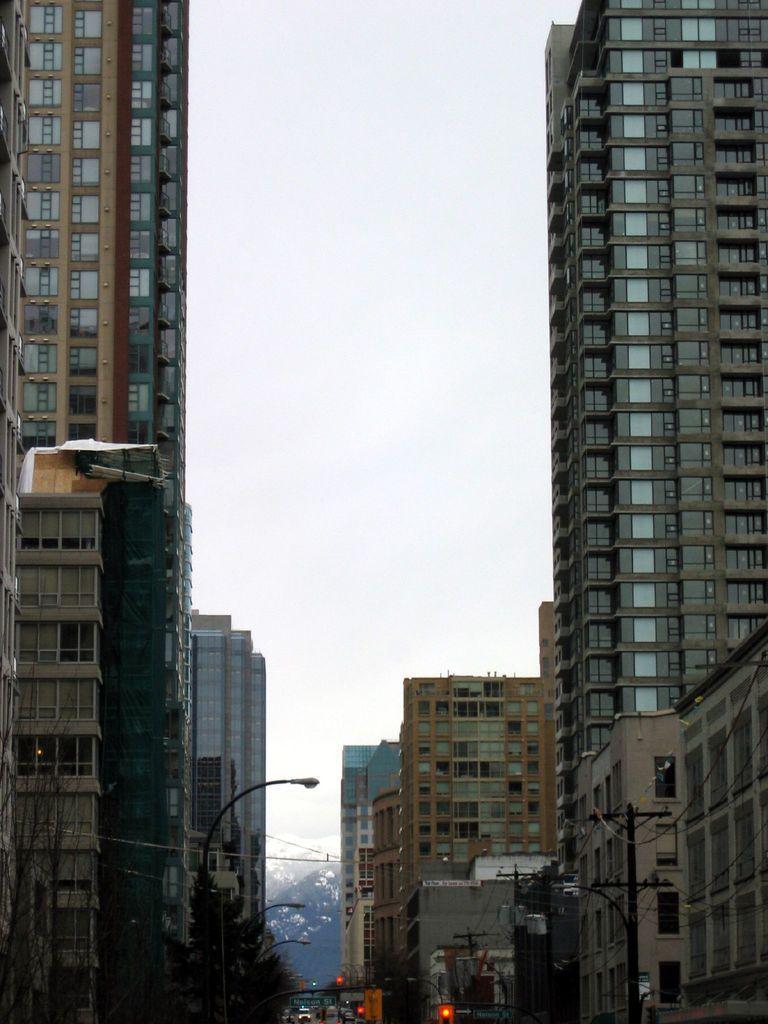How would you summarize this image in a sentence or two? In this image we can see buildings, windows, glass doors and at the bottom we can see trees, street lights, poles, wires, traffic signal poles. In the background we can see snow on the mountain and sky. 